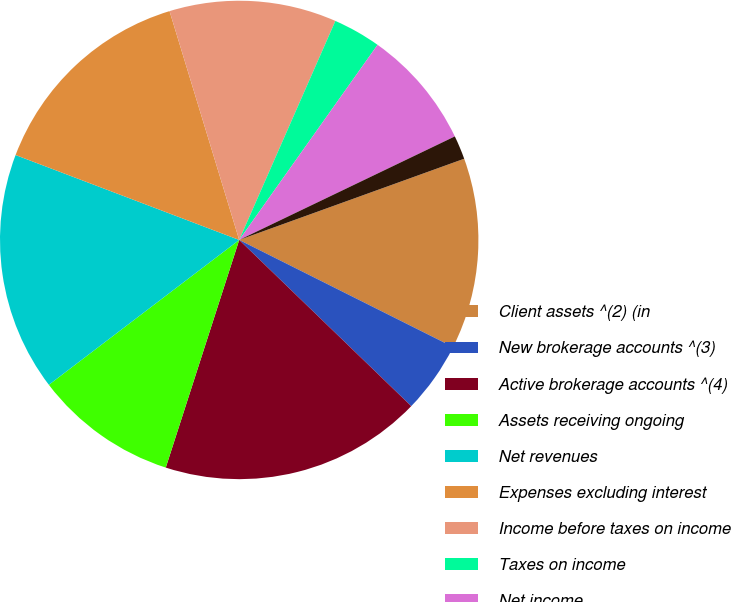Convert chart. <chart><loc_0><loc_0><loc_500><loc_500><pie_chart><fcel>Client assets ^(2) (in<fcel>New brokerage accounts ^(3)<fcel>Active brokerage accounts ^(4)<fcel>Assets receiving ongoing<fcel>Net revenues<fcel>Expenses excluding interest<fcel>Income before taxes on income<fcel>Taxes on income<fcel>Net income<fcel>Preferred stock dividends<nl><fcel>12.9%<fcel>4.84%<fcel>17.74%<fcel>9.68%<fcel>16.13%<fcel>14.52%<fcel>11.29%<fcel>3.23%<fcel>8.06%<fcel>1.61%<nl></chart> 